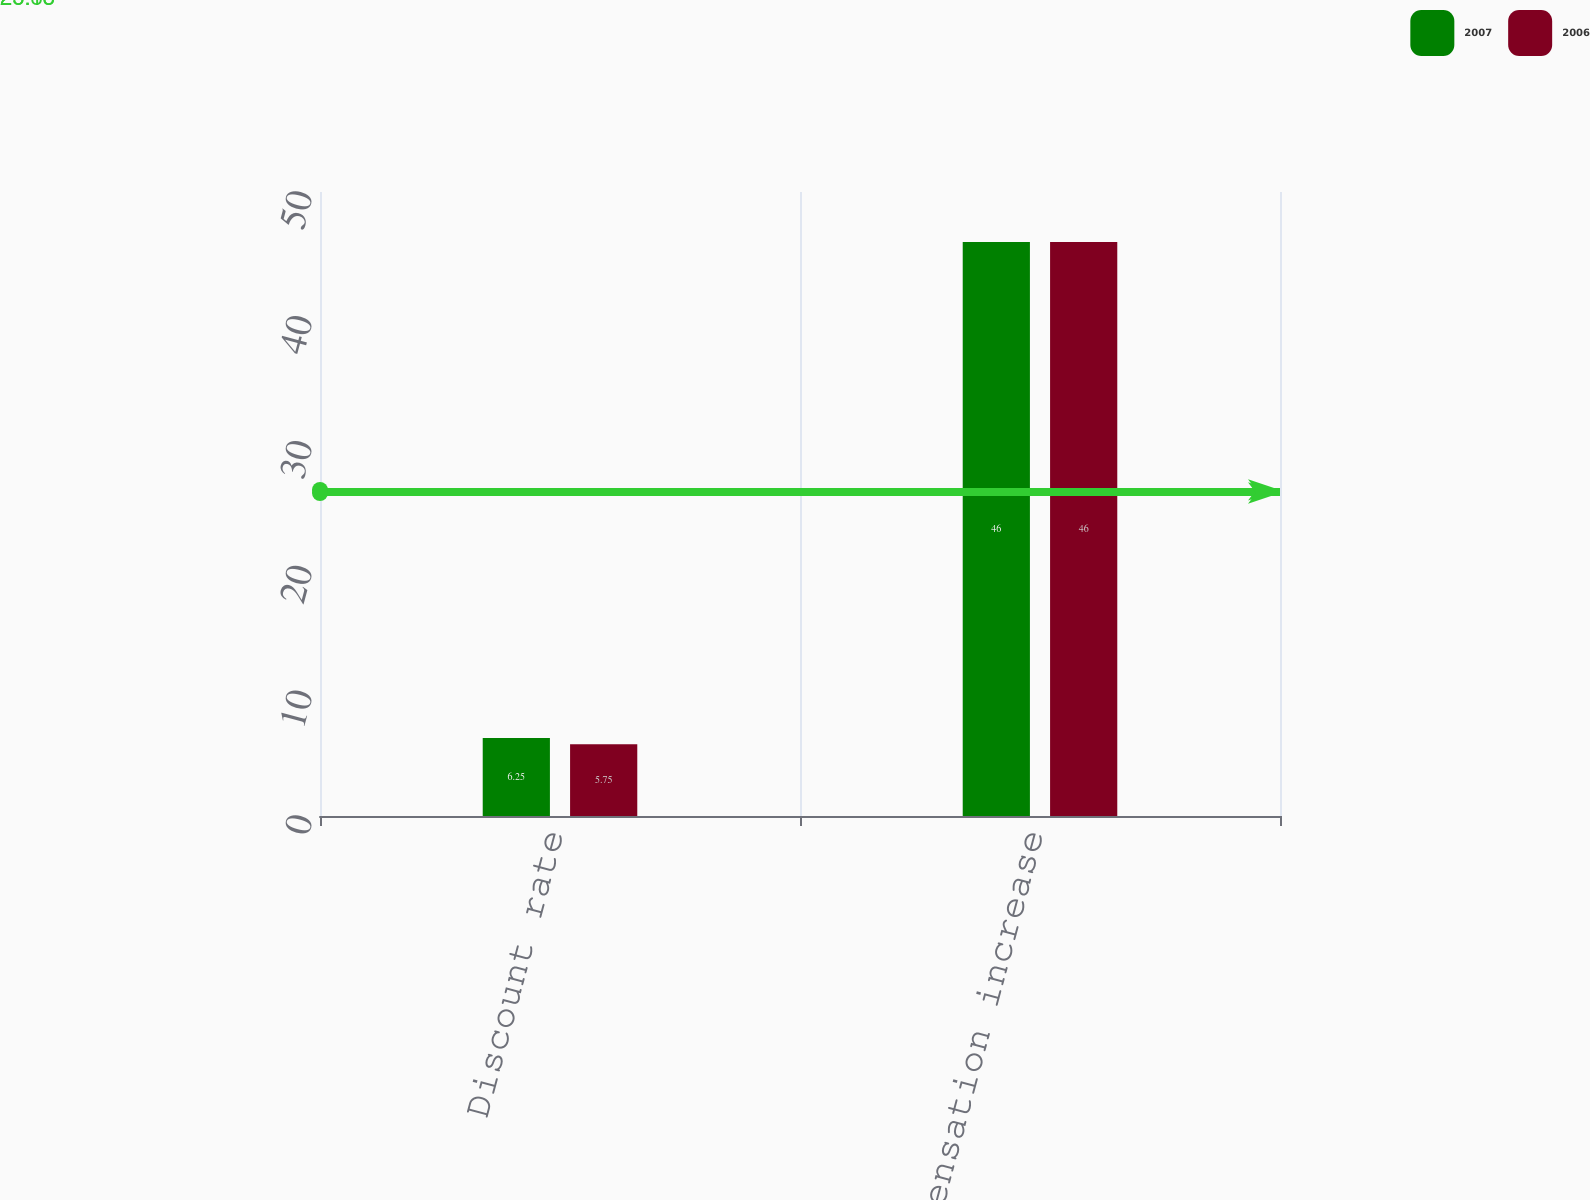Convert chart to OTSL. <chart><loc_0><loc_0><loc_500><loc_500><stacked_bar_chart><ecel><fcel>Discount rate<fcel>Rate of compensation increase<nl><fcel>2007<fcel>6.25<fcel>46<nl><fcel>2006<fcel>5.75<fcel>46<nl></chart> 